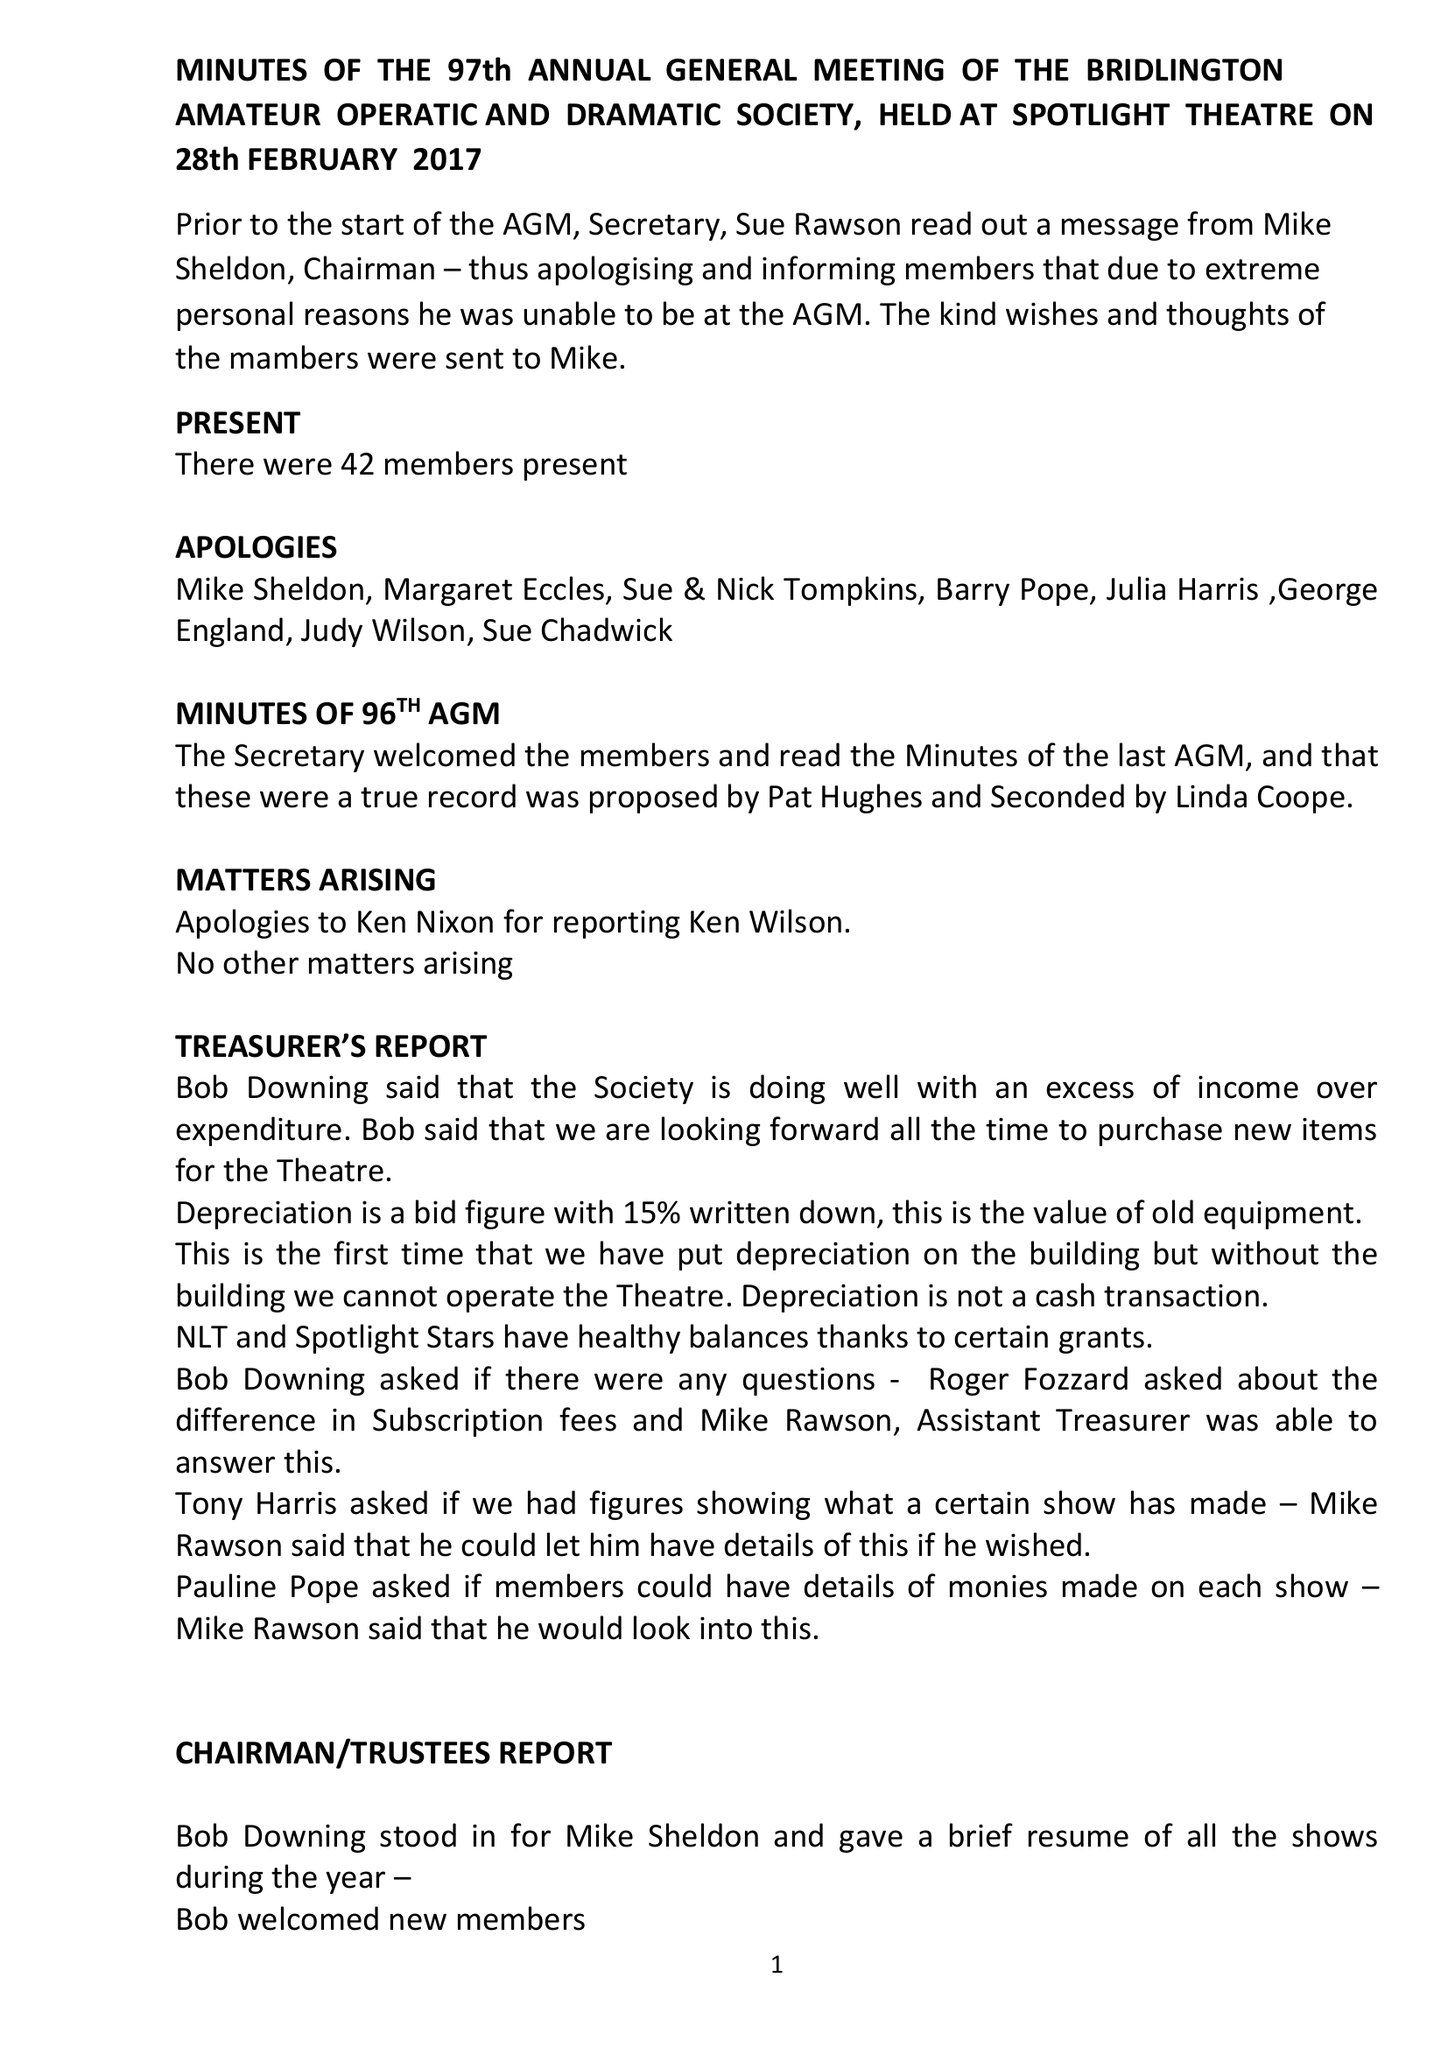What is the value for the address__postcode?
Answer the question using a single word or phrase. None 